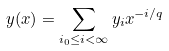Convert formula to latex. <formula><loc_0><loc_0><loc_500><loc_500>y ( x ) = \sum _ { i _ { 0 } \leq i < \infty } y _ { i } x ^ { - i / q }</formula> 